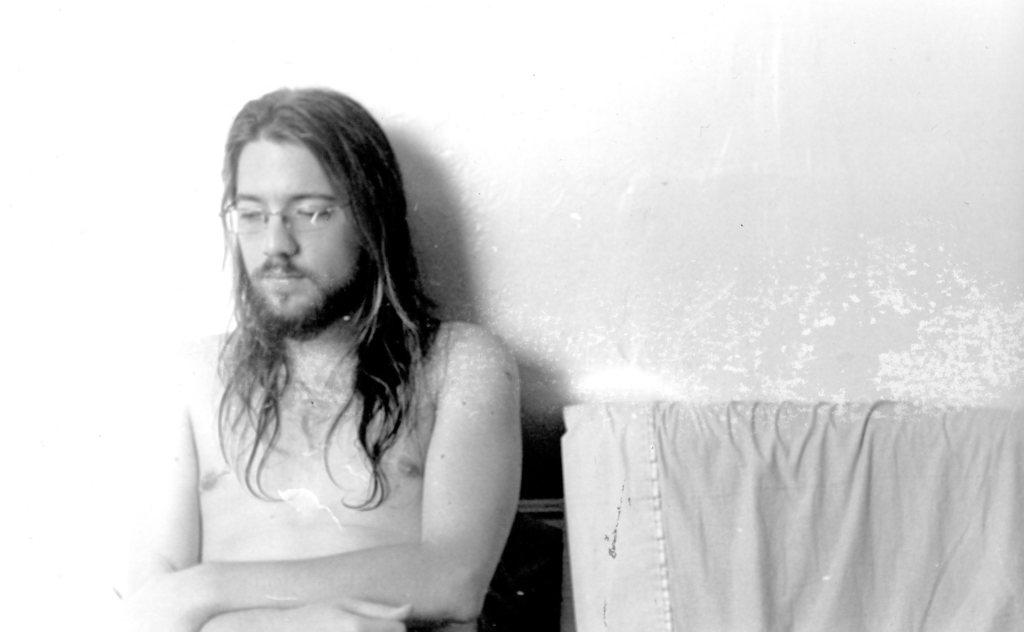What is the color scheme of the image? The image is black and white. Who is present in the image? There is a man in the image. What is the man wearing, or not wearing, in the image? The man is sitting without a shirt in the image. What object is located beside the man? There is a cloth beside the man. What can be seen in the background of the image? There is a wall in the background of the image. What type of toy can be seen in the man's hand in the image? There is no toy present in the image; the man is not holding anything in his hand. Can you describe the man's breathing pattern in the image? There is no information about the man's breathing pattern in the image, as it is a still photograph. 